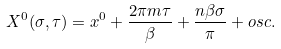Convert formula to latex. <formula><loc_0><loc_0><loc_500><loc_500>X ^ { 0 } ( \sigma , \tau ) = x ^ { 0 } + \frac { 2 \pi m \tau } { \beta } + \frac { n \beta \sigma } { \pi } + o s c .</formula> 